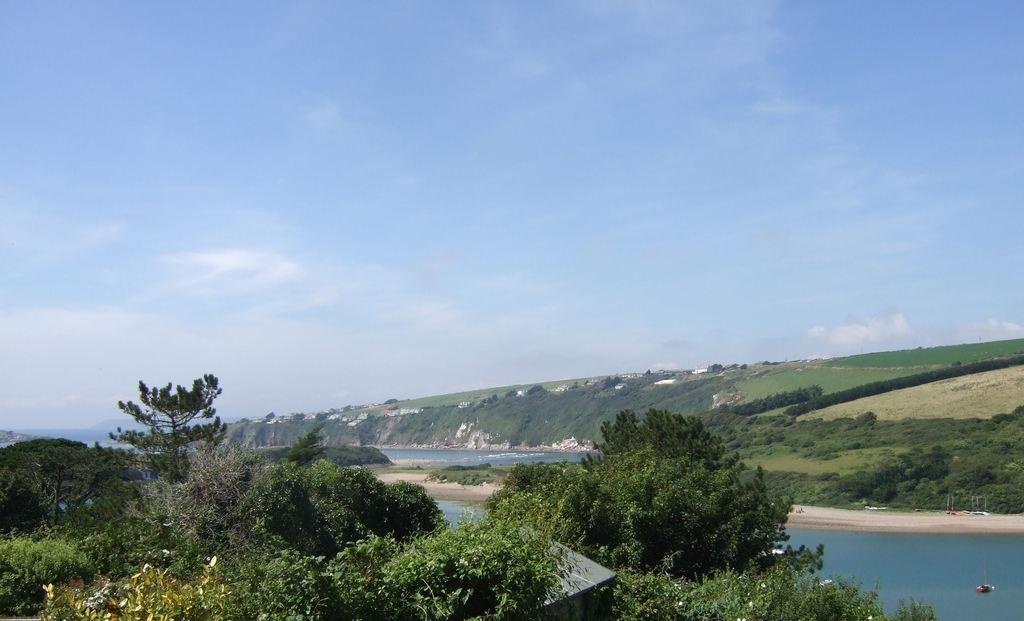What type of living organisms can be seen in the image? Plants can be seen in the image. What is the primary element visible in the image? Water is visible in the image. What type of vegetation is present in the image? Grass is present in the image. What is visible in the background of the image? The sky is visible in the background of the image. What colors can be seen in the sky? The sky has a combination of white and blue colors. What type of cable can be seen connecting the shoes in the image? There is no cable or shoes present in the image; it features plants, water, grass, and a sky with white and blue colors. 